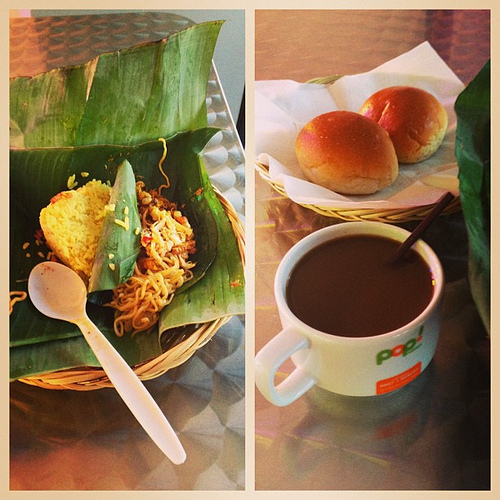What type of food is to the left of the mug? To the left of the mug is a tantalizing plate of noodles, neatly served on a banana leaf, inviting you to dig in. 